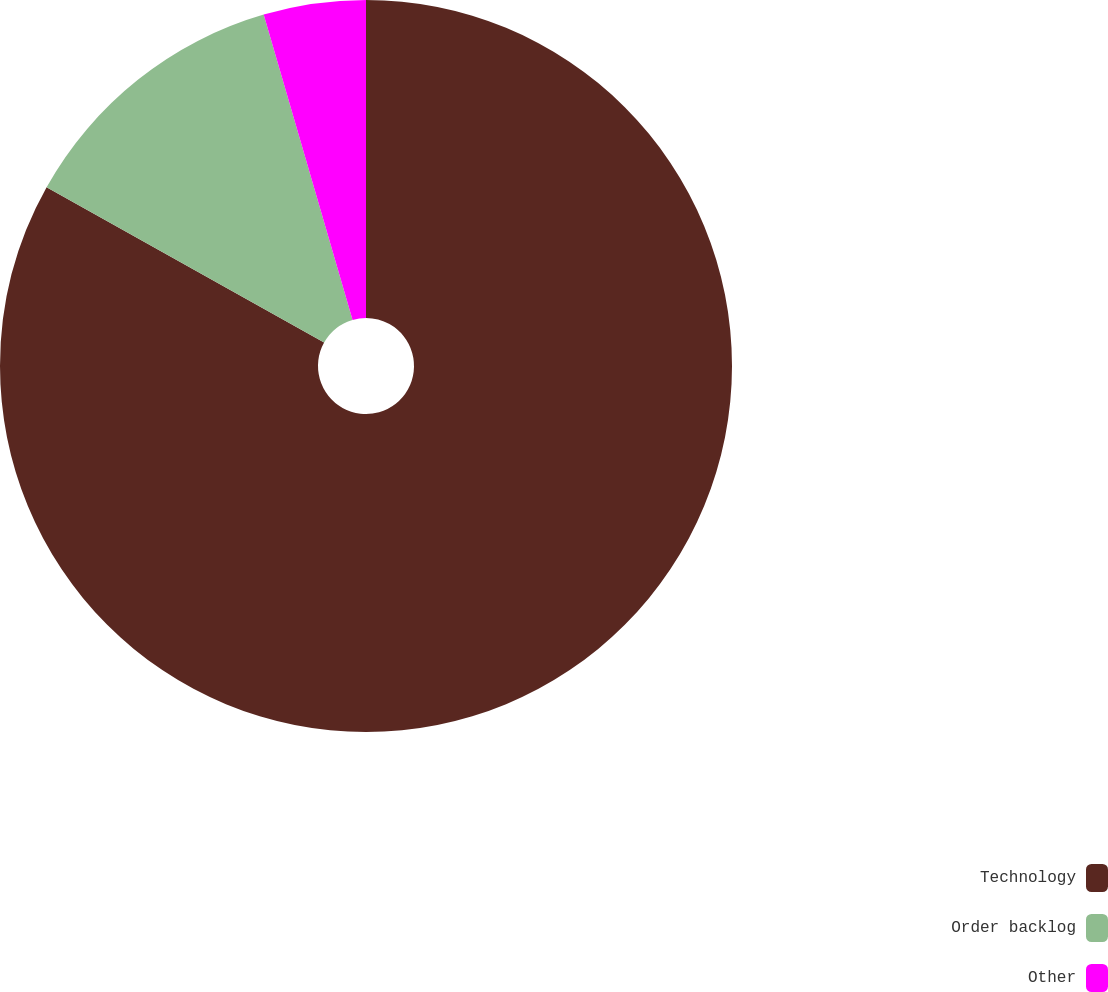Convert chart to OTSL. <chart><loc_0><loc_0><loc_500><loc_500><pie_chart><fcel>Technology<fcel>Order backlog<fcel>Other<nl><fcel>83.12%<fcel>12.37%<fcel>4.51%<nl></chart> 